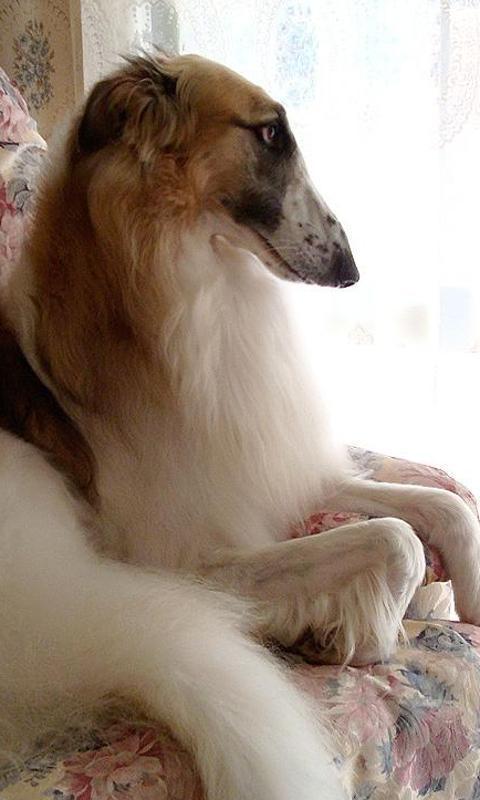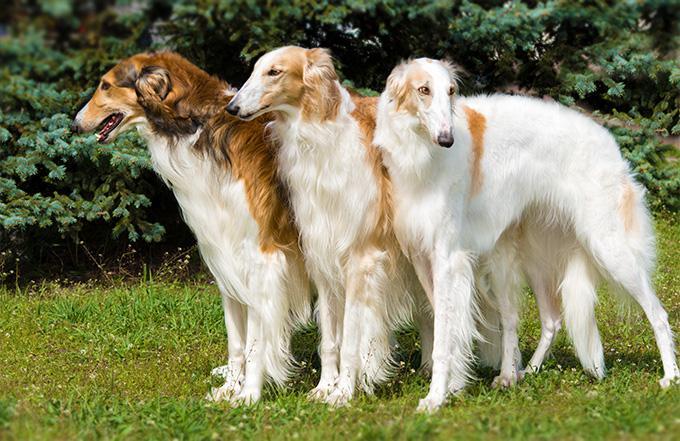The first image is the image on the left, the second image is the image on the right. Considering the images on both sides, is "There are at most two dogs." valid? Answer yes or no. No. The first image is the image on the left, the second image is the image on the right. Evaluate the accuracy of this statement regarding the images: "More than one quarter of the dogs has their mouth open.". Is it true? Answer yes or no. No. 